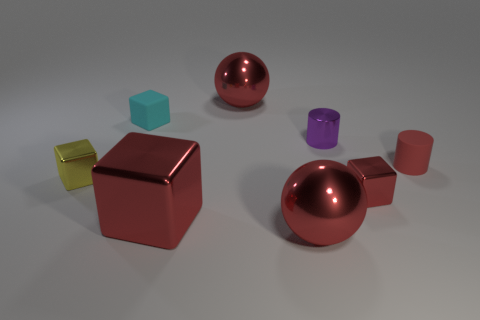There is a tiny thing that is the same color as the matte cylinder; what is its material?
Provide a succinct answer. Metal. Do the small cyan thing and the small yellow object have the same shape?
Keep it short and to the point. Yes. How many red metal things have the same size as the yellow metallic object?
Offer a terse response. 1. Are there fewer red cylinders behind the tiny red cylinder than tiny yellow blocks?
Offer a terse response. Yes. What is the size of the shiny block that is left of the cube that is behind the small red matte cylinder?
Keep it short and to the point. Small. What number of things are either red metallic cylinders or red metal things?
Provide a succinct answer. 4. Are there any big things of the same color as the small rubber cylinder?
Your answer should be very brief. Yes. Is the number of small green metal cylinders less than the number of cyan cubes?
Your answer should be very brief. Yes. How many objects are either cyan matte things or big red metallic spheres that are behind the cyan matte cube?
Offer a very short reply. 2. Is there a small thing made of the same material as the tiny red cylinder?
Offer a very short reply. Yes. 